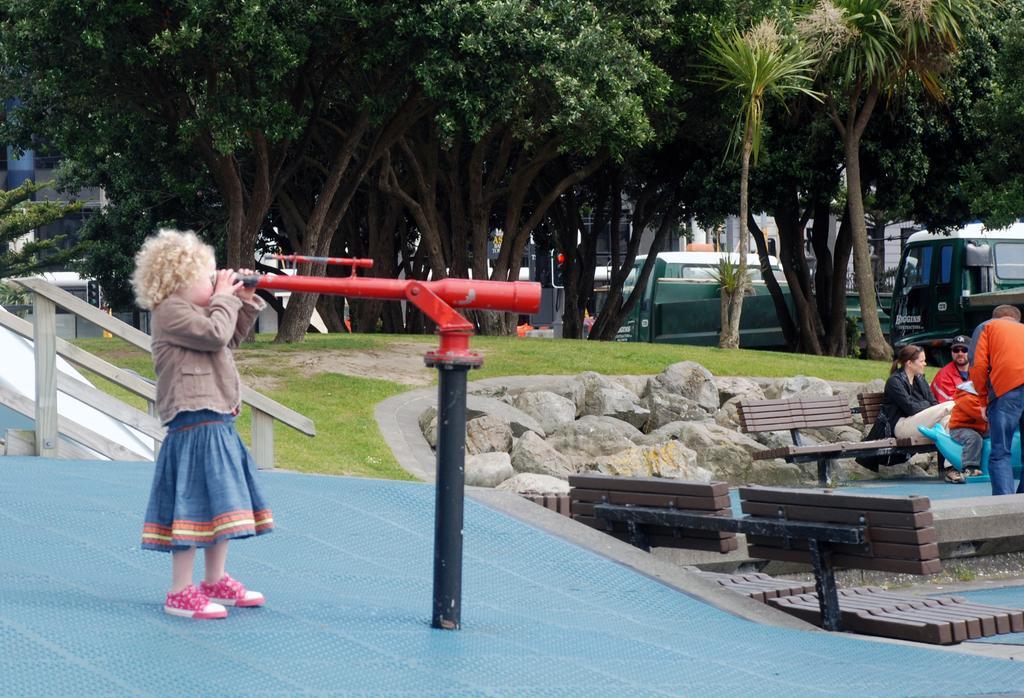Could you give a brief overview of what you see in this image? In this image there is a girl seeing through a telescope, in front of the girl, there are a few people seated on the benches, behind the benches there are rocks, behind the rocks there is grass on the surface, in the background of the image there are trees and cars parked. 